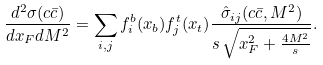<formula> <loc_0><loc_0><loc_500><loc_500>\frac { d ^ { 2 } \sigma ( c \bar { c } ) } { d x _ { F } d M ^ { 2 } } = \sum _ { i , j } f ^ { b } _ { i } ( x _ { b } ) f ^ { t } _ { j } ( x _ { t } ) \frac { \hat { \sigma } _ { i j } ( c \bar { c } , M ^ { 2 } ) } { s \, \sqrt { x _ { F } ^ { 2 } + \frac { 4 M ^ { 2 } } { s } } } .</formula> 